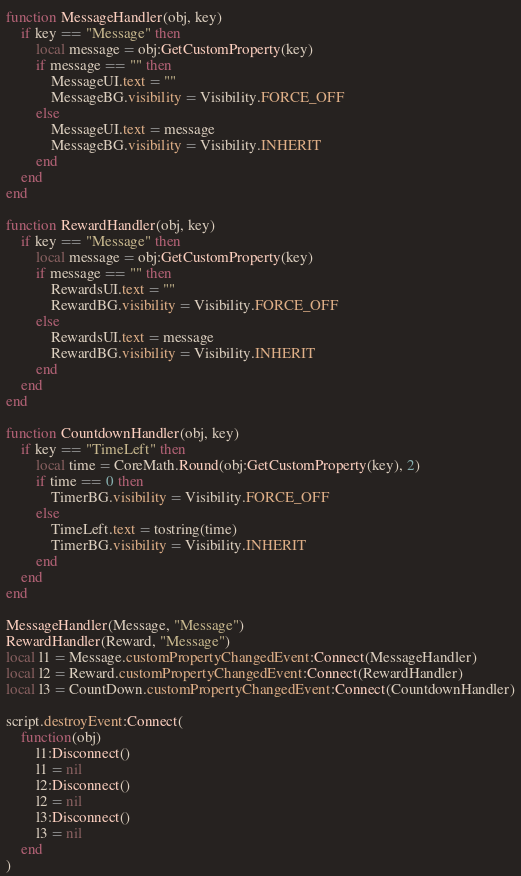<code> <loc_0><loc_0><loc_500><loc_500><_Lua_>
function MessageHandler(obj, key)
    if key == "Message" then
        local message = obj:GetCustomProperty(key)
        if message == "" then
            MessageUI.text = ""
            MessageBG.visibility = Visibility.FORCE_OFF
        else
            MessageUI.text = message
            MessageBG.visibility = Visibility.INHERIT
        end
    end
end

function RewardHandler(obj, key)
    if key == "Message" then
        local message = obj:GetCustomProperty(key)
        if message == "" then
            RewardsUI.text = ""
            RewardBG.visibility = Visibility.FORCE_OFF
        else
            RewardsUI.text = message
            RewardBG.visibility = Visibility.INHERIT
        end
    end
end

function CountdownHandler(obj, key)
    if key == "TimeLeft" then
        local time = CoreMath.Round(obj:GetCustomProperty(key), 2)
        if time == 0 then
            TimerBG.visibility = Visibility.FORCE_OFF
        else
            TimeLeft.text = tostring(time)
            TimerBG.visibility = Visibility.INHERIT
        end
    end
end

MessageHandler(Message, "Message")
RewardHandler(Reward, "Message")
local l1 = Message.customPropertyChangedEvent:Connect(MessageHandler)
local l2 = Reward.customPropertyChangedEvent:Connect(RewardHandler)
local l3 = CountDown.customPropertyChangedEvent:Connect(CountdownHandler)

script.destroyEvent:Connect(
    function(obj)
        l1:Disconnect()
        l1 = nil
        l2:Disconnect()
        l2 = nil
        l3:Disconnect()
        l3 = nil
    end
)
</code> 